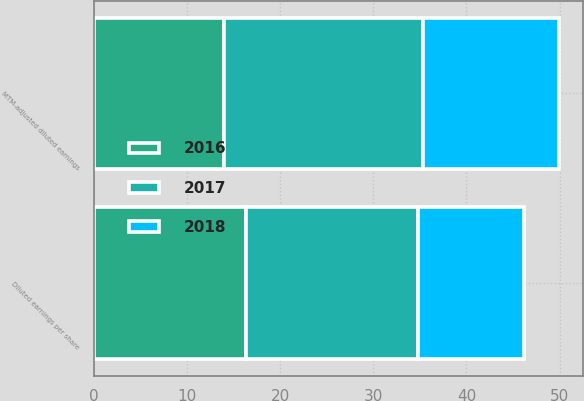<chart> <loc_0><loc_0><loc_500><loc_500><stacked_bar_chart><ecel><fcel>Diluted earnings per share<fcel>MTM-adjusted diluted earnings<nl><fcel>2017<fcel>18.49<fcel>21.33<nl><fcel>2016<fcel>16.34<fcel>14.04<nl><fcel>2018<fcel>11.32<fcel>14.59<nl></chart> 